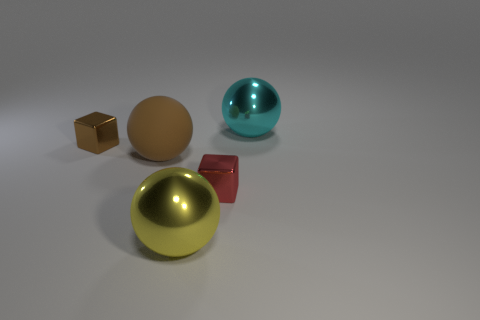What kind of lighting setup might have been used to create the shadows in the image? The image seems to be illuminated with a soft, diffused overhead light source, given the soft-edged shadows cast directly underneath each object. The lack of multiple shadows or harsh lines suggests there aren't additional strong light sources. This type of lighting can be achieved in a studio setting with a single, broad light source or by using a softer light modifiers like a diffuser or softbox. 